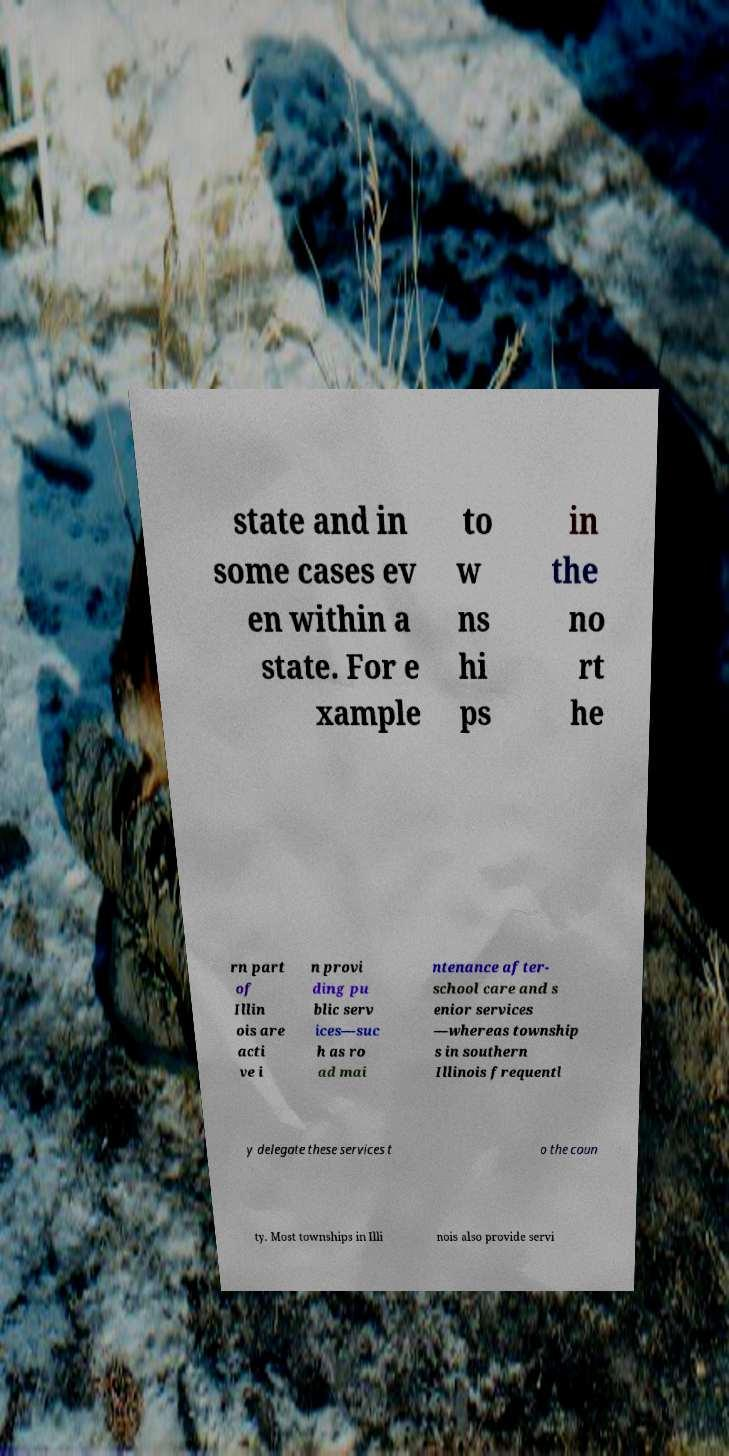Can you accurately transcribe the text from the provided image for me? state and in some cases ev en within a state. For e xample to w ns hi ps in the no rt he rn part of Illin ois are acti ve i n provi ding pu blic serv ices—suc h as ro ad mai ntenance after- school care and s enior services —whereas township s in southern Illinois frequentl y delegate these services t o the coun ty. Most townships in Illi nois also provide servi 